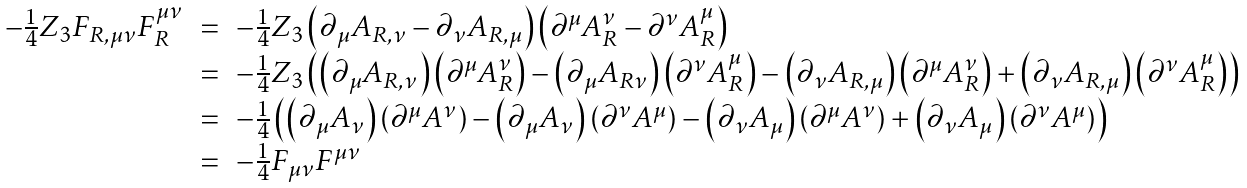Convert formula to latex. <formula><loc_0><loc_0><loc_500><loc_500>\begin{array} { r c l } - \frac { 1 } { 4 } Z _ { 3 } F _ { R , \mu \nu } F _ { R } ^ { \mu \nu } & = & - \frac { 1 } { 4 } Z _ { 3 } \left ( \partial _ { \mu } A _ { R , \nu } - \partial _ { \nu } A _ { R , \mu } \right ) \left ( \partial ^ { \mu } A _ { R } ^ { \nu } - \partial ^ { \nu } A _ { R } ^ { \mu } \right ) \\ & = & - \frac { 1 } { 4 } Z _ { 3 } \left ( \left ( \partial _ { \mu } A _ { R , \nu } \right ) \left ( \partial ^ { \mu } A _ { R } ^ { \nu } \right ) - \left ( \partial _ { \mu } A _ { R \nu } \right ) \left ( \partial ^ { \nu } A _ { R } ^ { \mu } \right ) - \left ( \partial _ { \nu } A _ { R , \mu } \right ) \left ( \partial ^ { \mu } A _ { R } ^ { \nu } \right ) + \left ( \partial _ { \nu } A _ { R , \mu } \right ) \left ( \partial ^ { \nu } A _ { R } ^ { \mu } \right ) \right ) \\ & = & - \frac { 1 } { 4 } \left ( \left ( \partial _ { \mu } A _ { \nu } \right ) \left ( \partial ^ { \mu } A ^ { \nu } \right ) - \left ( \partial _ { \mu } A _ { \nu } \right ) \left ( \partial ^ { \nu } A ^ { \mu } \right ) - \left ( \partial _ { \nu } A _ { \mu } \right ) \left ( \partial ^ { \mu } A ^ { \nu } \right ) + \left ( \partial _ { \nu } A _ { \mu } \right ) \left ( \partial ^ { \nu } A ^ { \mu } \right ) \right ) \\ & = & - \frac { 1 } { 4 } F _ { \mu \nu } F ^ { \mu \nu } \end{array}</formula> 